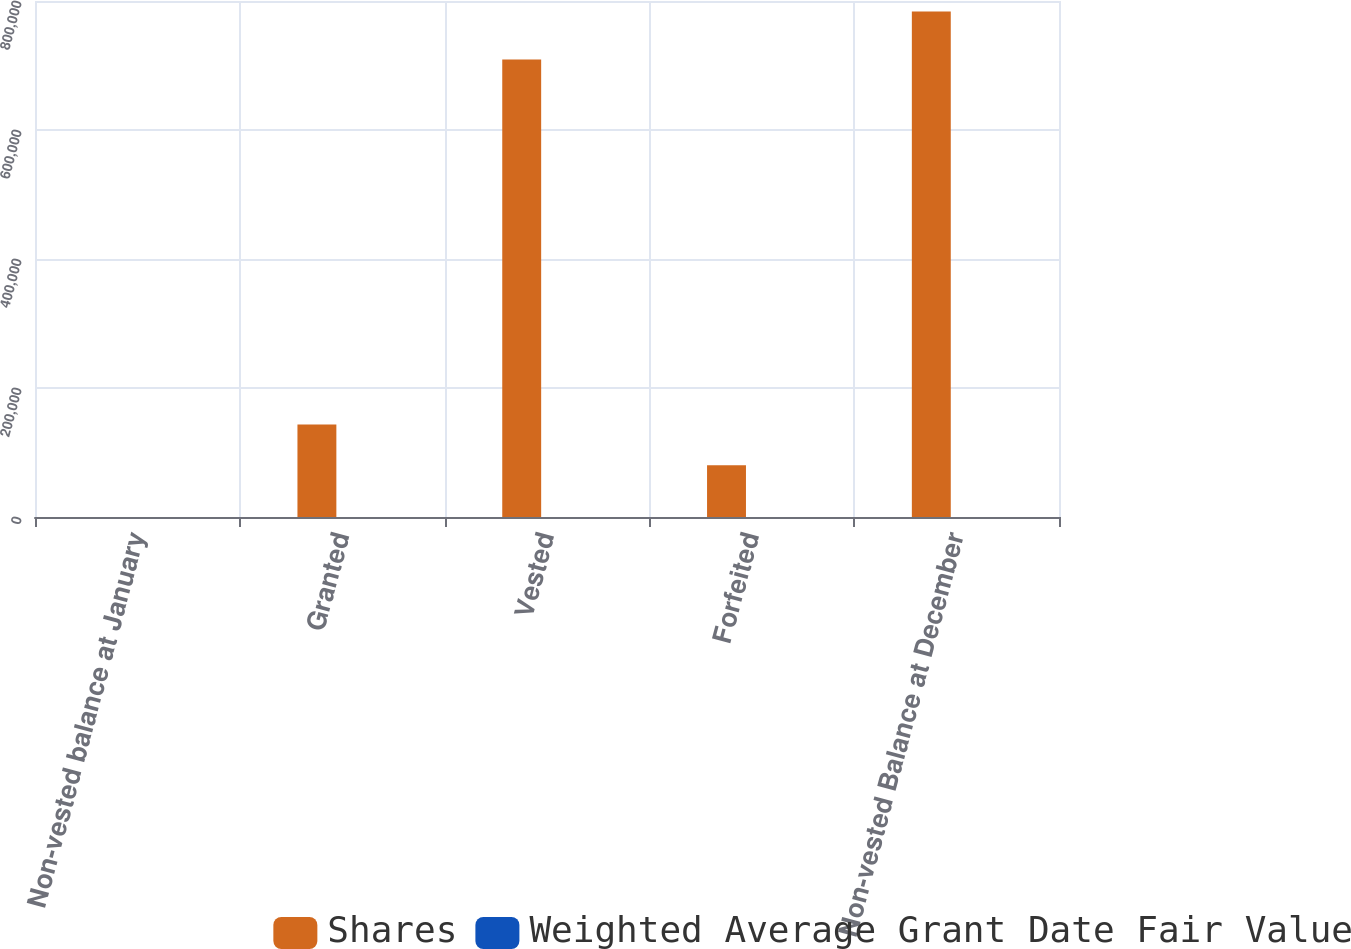<chart> <loc_0><loc_0><loc_500><loc_500><stacked_bar_chart><ecel><fcel>Non-vested balance at January<fcel>Granted<fcel>Vested<fcel>Forfeited<fcel>Non-vested Balance at December<nl><fcel>Shares<fcel>48.57<fcel>143291<fcel>709184<fcel>80420<fcel>783585<nl><fcel>Weighted Average Grant Date Fair Value<fcel>44.4<fcel>29.43<fcel>44.94<fcel>48.57<fcel>40.74<nl></chart> 